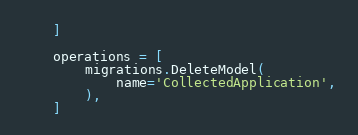<code> <loc_0><loc_0><loc_500><loc_500><_Python_>    ]

    operations = [
        migrations.DeleteModel(
            name='CollectedApplication',
        ),
    ]
</code> 